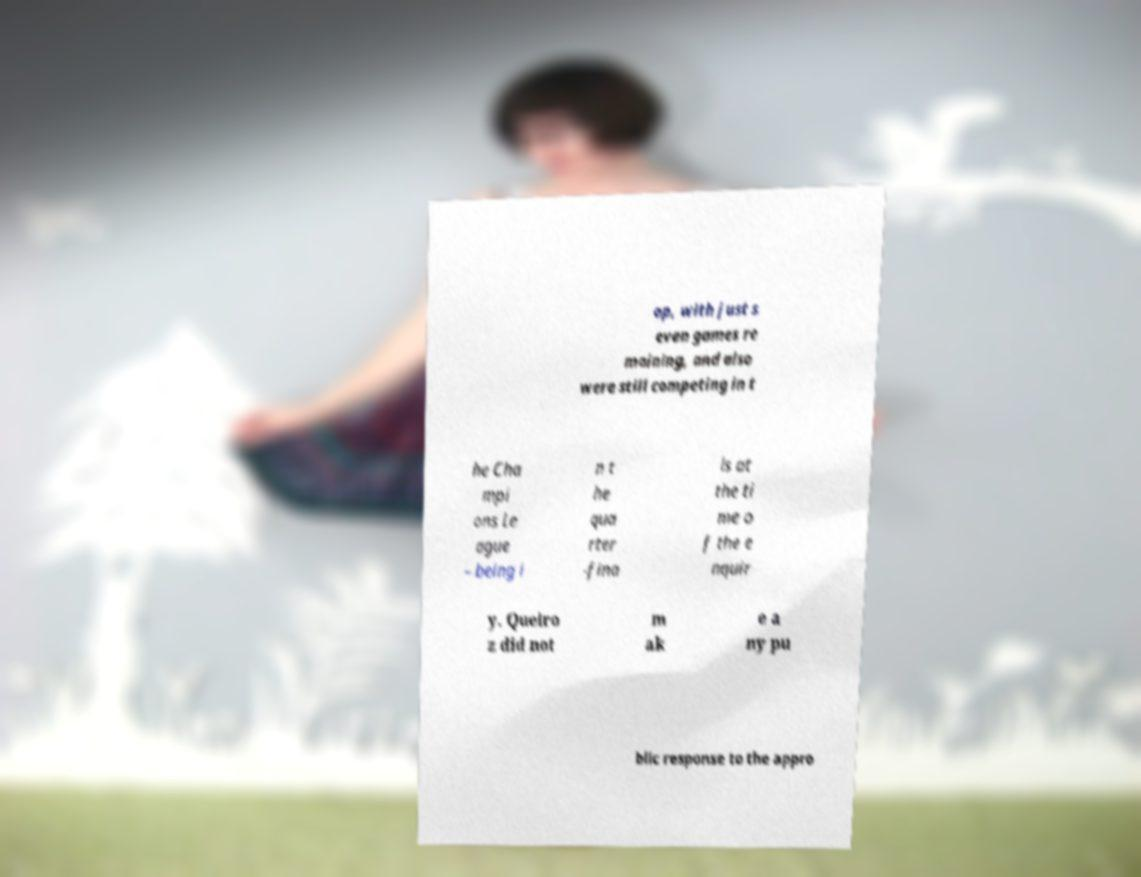For documentation purposes, I need the text within this image transcribed. Could you provide that? op, with just s even games re maining, and also were still competing in t he Cha mpi ons Le ague – being i n t he qua rter -fina ls at the ti me o f the e nquir y. Queiro z did not m ak e a ny pu blic response to the appro 